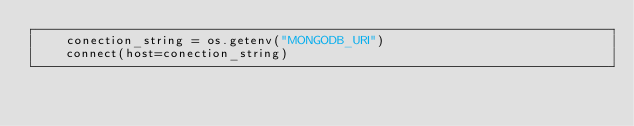<code> <loc_0><loc_0><loc_500><loc_500><_Python_>    conection_string = os.getenv("MONGODB_URI")
    connect(host=conection_string)

</code> 